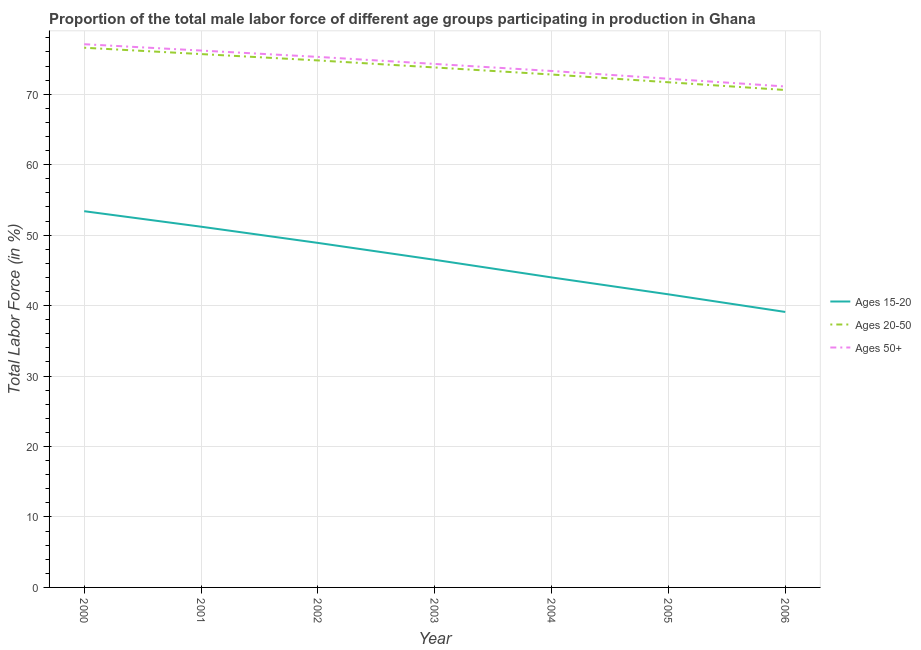How many different coloured lines are there?
Keep it short and to the point. 3. What is the percentage of male labor force above age 50 in 2003?
Your response must be concise. 74.3. Across all years, what is the maximum percentage of male labor force within the age group 15-20?
Give a very brief answer. 53.4. Across all years, what is the minimum percentage of male labor force above age 50?
Offer a terse response. 71.1. In which year was the percentage of male labor force within the age group 20-50 maximum?
Provide a succinct answer. 2000. In which year was the percentage of male labor force above age 50 minimum?
Your answer should be compact. 2006. What is the total percentage of male labor force above age 50 in the graph?
Make the answer very short. 519.5. What is the difference between the percentage of male labor force within the age group 15-20 in 2000 and that in 2001?
Your answer should be very brief. 2.2. What is the difference between the percentage of male labor force within the age group 20-50 in 2002 and the percentage of male labor force above age 50 in 2003?
Offer a terse response. 0.5. What is the average percentage of male labor force within the age group 20-50 per year?
Your answer should be very brief. 73.71. What is the ratio of the percentage of male labor force within the age group 20-50 in 2003 to that in 2006?
Provide a succinct answer. 1.05. Is the percentage of male labor force above age 50 in 2000 less than that in 2004?
Your answer should be very brief. No. What is the difference between the highest and the second highest percentage of male labor force above age 50?
Keep it short and to the point. 0.9. What is the difference between the highest and the lowest percentage of male labor force within the age group 15-20?
Make the answer very short. 14.3. In how many years, is the percentage of male labor force above age 50 greater than the average percentage of male labor force above age 50 taken over all years?
Ensure brevity in your answer.  4. How many years are there in the graph?
Your answer should be very brief. 7. What is the difference between two consecutive major ticks on the Y-axis?
Offer a very short reply. 10. Are the values on the major ticks of Y-axis written in scientific E-notation?
Offer a terse response. No. Does the graph contain grids?
Give a very brief answer. Yes. Where does the legend appear in the graph?
Your answer should be compact. Center right. How are the legend labels stacked?
Keep it short and to the point. Vertical. What is the title of the graph?
Your answer should be very brief. Proportion of the total male labor force of different age groups participating in production in Ghana. What is the label or title of the Y-axis?
Make the answer very short. Total Labor Force (in %). What is the Total Labor Force (in %) of Ages 15-20 in 2000?
Offer a terse response. 53.4. What is the Total Labor Force (in %) in Ages 20-50 in 2000?
Your answer should be very brief. 76.6. What is the Total Labor Force (in %) in Ages 50+ in 2000?
Make the answer very short. 77.1. What is the Total Labor Force (in %) in Ages 15-20 in 2001?
Provide a succinct answer. 51.2. What is the Total Labor Force (in %) of Ages 20-50 in 2001?
Provide a short and direct response. 75.7. What is the Total Labor Force (in %) in Ages 50+ in 2001?
Your answer should be compact. 76.2. What is the Total Labor Force (in %) in Ages 15-20 in 2002?
Offer a very short reply. 48.9. What is the Total Labor Force (in %) of Ages 20-50 in 2002?
Ensure brevity in your answer.  74.8. What is the Total Labor Force (in %) in Ages 50+ in 2002?
Give a very brief answer. 75.3. What is the Total Labor Force (in %) of Ages 15-20 in 2003?
Your answer should be very brief. 46.5. What is the Total Labor Force (in %) of Ages 20-50 in 2003?
Ensure brevity in your answer.  73.8. What is the Total Labor Force (in %) of Ages 50+ in 2003?
Your answer should be very brief. 74.3. What is the Total Labor Force (in %) in Ages 20-50 in 2004?
Give a very brief answer. 72.8. What is the Total Labor Force (in %) in Ages 50+ in 2004?
Ensure brevity in your answer.  73.3. What is the Total Labor Force (in %) of Ages 15-20 in 2005?
Provide a short and direct response. 41.6. What is the Total Labor Force (in %) in Ages 20-50 in 2005?
Your response must be concise. 71.7. What is the Total Labor Force (in %) of Ages 50+ in 2005?
Your answer should be compact. 72.2. What is the Total Labor Force (in %) of Ages 15-20 in 2006?
Your answer should be very brief. 39.1. What is the Total Labor Force (in %) of Ages 20-50 in 2006?
Provide a succinct answer. 70.6. What is the Total Labor Force (in %) in Ages 50+ in 2006?
Offer a very short reply. 71.1. Across all years, what is the maximum Total Labor Force (in %) of Ages 15-20?
Your response must be concise. 53.4. Across all years, what is the maximum Total Labor Force (in %) in Ages 20-50?
Provide a short and direct response. 76.6. Across all years, what is the maximum Total Labor Force (in %) of Ages 50+?
Your response must be concise. 77.1. Across all years, what is the minimum Total Labor Force (in %) of Ages 15-20?
Offer a terse response. 39.1. Across all years, what is the minimum Total Labor Force (in %) of Ages 20-50?
Provide a short and direct response. 70.6. Across all years, what is the minimum Total Labor Force (in %) in Ages 50+?
Offer a terse response. 71.1. What is the total Total Labor Force (in %) of Ages 15-20 in the graph?
Your response must be concise. 324.7. What is the total Total Labor Force (in %) of Ages 20-50 in the graph?
Give a very brief answer. 516. What is the total Total Labor Force (in %) in Ages 50+ in the graph?
Your answer should be very brief. 519.5. What is the difference between the Total Labor Force (in %) of Ages 20-50 in 2000 and that in 2001?
Give a very brief answer. 0.9. What is the difference between the Total Labor Force (in %) in Ages 50+ in 2000 and that in 2001?
Keep it short and to the point. 0.9. What is the difference between the Total Labor Force (in %) of Ages 20-50 in 2000 and that in 2002?
Keep it short and to the point. 1.8. What is the difference between the Total Labor Force (in %) in Ages 50+ in 2000 and that in 2002?
Offer a very short reply. 1.8. What is the difference between the Total Labor Force (in %) in Ages 15-20 in 2000 and that in 2003?
Provide a succinct answer. 6.9. What is the difference between the Total Labor Force (in %) in Ages 15-20 in 2000 and that in 2004?
Give a very brief answer. 9.4. What is the difference between the Total Labor Force (in %) in Ages 20-50 in 2000 and that in 2004?
Provide a succinct answer. 3.8. What is the difference between the Total Labor Force (in %) in Ages 15-20 in 2000 and that in 2005?
Provide a short and direct response. 11.8. What is the difference between the Total Labor Force (in %) of Ages 20-50 in 2000 and that in 2005?
Offer a very short reply. 4.9. What is the difference between the Total Labor Force (in %) of Ages 50+ in 2000 and that in 2005?
Ensure brevity in your answer.  4.9. What is the difference between the Total Labor Force (in %) of Ages 15-20 in 2000 and that in 2006?
Provide a succinct answer. 14.3. What is the difference between the Total Labor Force (in %) in Ages 20-50 in 2000 and that in 2006?
Make the answer very short. 6. What is the difference between the Total Labor Force (in %) of Ages 50+ in 2000 and that in 2006?
Your answer should be very brief. 6. What is the difference between the Total Labor Force (in %) of Ages 50+ in 2001 and that in 2003?
Make the answer very short. 1.9. What is the difference between the Total Labor Force (in %) of Ages 15-20 in 2001 and that in 2004?
Your answer should be very brief. 7.2. What is the difference between the Total Labor Force (in %) of Ages 15-20 in 2001 and that in 2005?
Provide a succinct answer. 9.6. What is the difference between the Total Labor Force (in %) of Ages 15-20 in 2001 and that in 2006?
Make the answer very short. 12.1. What is the difference between the Total Labor Force (in %) in Ages 50+ in 2001 and that in 2006?
Keep it short and to the point. 5.1. What is the difference between the Total Labor Force (in %) in Ages 20-50 in 2002 and that in 2003?
Make the answer very short. 1. What is the difference between the Total Labor Force (in %) in Ages 15-20 in 2002 and that in 2005?
Provide a short and direct response. 7.3. What is the difference between the Total Labor Force (in %) of Ages 50+ in 2002 and that in 2005?
Offer a terse response. 3.1. What is the difference between the Total Labor Force (in %) of Ages 15-20 in 2002 and that in 2006?
Your response must be concise. 9.8. What is the difference between the Total Labor Force (in %) in Ages 20-50 in 2002 and that in 2006?
Provide a short and direct response. 4.2. What is the difference between the Total Labor Force (in %) in Ages 15-20 in 2003 and that in 2004?
Provide a succinct answer. 2.5. What is the difference between the Total Labor Force (in %) in Ages 20-50 in 2003 and that in 2004?
Provide a short and direct response. 1. What is the difference between the Total Labor Force (in %) of Ages 50+ in 2003 and that in 2004?
Ensure brevity in your answer.  1. What is the difference between the Total Labor Force (in %) in Ages 15-20 in 2003 and that in 2005?
Offer a very short reply. 4.9. What is the difference between the Total Labor Force (in %) in Ages 20-50 in 2003 and that in 2005?
Offer a terse response. 2.1. What is the difference between the Total Labor Force (in %) of Ages 20-50 in 2003 and that in 2006?
Offer a terse response. 3.2. What is the difference between the Total Labor Force (in %) in Ages 50+ in 2003 and that in 2006?
Make the answer very short. 3.2. What is the difference between the Total Labor Force (in %) in Ages 15-20 in 2004 and that in 2005?
Provide a succinct answer. 2.4. What is the difference between the Total Labor Force (in %) in Ages 50+ in 2004 and that in 2005?
Your answer should be compact. 1.1. What is the difference between the Total Labor Force (in %) in Ages 15-20 in 2004 and that in 2006?
Your answer should be very brief. 4.9. What is the difference between the Total Labor Force (in %) in Ages 20-50 in 2005 and that in 2006?
Your answer should be very brief. 1.1. What is the difference between the Total Labor Force (in %) of Ages 15-20 in 2000 and the Total Labor Force (in %) of Ages 20-50 in 2001?
Your answer should be compact. -22.3. What is the difference between the Total Labor Force (in %) in Ages 15-20 in 2000 and the Total Labor Force (in %) in Ages 50+ in 2001?
Make the answer very short. -22.8. What is the difference between the Total Labor Force (in %) of Ages 20-50 in 2000 and the Total Labor Force (in %) of Ages 50+ in 2001?
Give a very brief answer. 0.4. What is the difference between the Total Labor Force (in %) of Ages 15-20 in 2000 and the Total Labor Force (in %) of Ages 20-50 in 2002?
Give a very brief answer. -21.4. What is the difference between the Total Labor Force (in %) in Ages 15-20 in 2000 and the Total Labor Force (in %) in Ages 50+ in 2002?
Give a very brief answer. -21.9. What is the difference between the Total Labor Force (in %) in Ages 20-50 in 2000 and the Total Labor Force (in %) in Ages 50+ in 2002?
Your response must be concise. 1.3. What is the difference between the Total Labor Force (in %) of Ages 15-20 in 2000 and the Total Labor Force (in %) of Ages 20-50 in 2003?
Ensure brevity in your answer.  -20.4. What is the difference between the Total Labor Force (in %) of Ages 15-20 in 2000 and the Total Labor Force (in %) of Ages 50+ in 2003?
Make the answer very short. -20.9. What is the difference between the Total Labor Force (in %) in Ages 20-50 in 2000 and the Total Labor Force (in %) in Ages 50+ in 2003?
Keep it short and to the point. 2.3. What is the difference between the Total Labor Force (in %) in Ages 15-20 in 2000 and the Total Labor Force (in %) in Ages 20-50 in 2004?
Your response must be concise. -19.4. What is the difference between the Total Labor Force (in %) in Ages 15-20 in 2000 and the Total Labor Force (in %) in Ages 50+ in 2004?
Offer a terse response. -19.9. What is the difference between the Total Labor Force (in %) of Ages 15-20 in 2000 and the Total Labor Force (in %) of Ages 20-50 in 2005?
Keep it short and to the point. -18.3. What is the difference between the Total Labor Force (in %) in Ages 15-20 in 2000 and the Total Labor Force (in %) in Ages 50+ in 2005?
Your answer should be compact. -18.8. What is the difference between the Total Labor Force (in %) of Ages 20-50 in 2000 and the Total Labor Force (in %) of Ages 50+ in 2005?
Your response must be concise. 4.4. What is the difference between the Total Labor Force (in %) of Ages 15-20 in 2000 and the Total Labor Force (in %) of Ages 20-50 in 2006?
Ensure brevity in your answer.  -17.2. What is the difference between the Total Labor Force (in %) of Ages 15-20 in 2000 and the Total Labor Force (in %) of Ages 50+ in 2006?
Provide a succinct answer. -17.7. What is the difference between the Total Labor Force (in %) in Ages 15-20 in 2001 and the Total Labor Force (in %) in Ages 20-50 in 2002?
Keep it short and to the point. -23.6. What is the difference between the Total Labor Force (in %) in Ages 15-20 in 2001 and the Total Labor Force (in %) in Ages 50+ in 2002?
Provide a short and direct response. -24.1. What is the difference between the Total Labor Force (in %) in Ages 15-20 in 2001 and the Total Labor Force (in %) in Ages 20-50 in 2003?
Give a very brief answer. -22.6. What is the difference between the Total Labor Force (in %) in Ages 15-20 in 2001 and the Total Labor Force (in %) in Ages 50+ in 2003?
Your response must be concise. -23.1. What is the difference between the Total Labor Force (in %) in Ages 15-20 in 2001 and the Total Labor Force (in %) in Ages 20-50 in 2004?
Provide a succinct answer. -21.6. What is the difference between the Total Labor Force (in %) of Ages 15-20 in 2001 and the Total Labor Force (in %) of Ages 50+ in 2004?
Make the answer very short. -22.1. What is the difference between the Total Labor Force (in %) in Ages 20-50 in 2001 and the Total Labor Force (in %) in Ages 50+ in 2004?
Ensure brevity in your answer.  2.4. What is the difference between the Total Labor Force (in %) of Ages 15-20 in 2001 and the Total Labor Force (in %) of Ages 20-50 in 2005?
Provide a succinct answer. -20.5. What is the difference between the Total Labor Force (in %) in Ages 15-20 in 2001 and the Total Labor Force (in %) in Ages 50+ in 2005?
Provide a short and direct response. -21. What is the difference between the Total Labor Force (in %) in Ages 20-50 in 2001 and the Total Labor Force (in %) in Ages 50+ in 2005?
Your answer should be compact. 3.5. What is the difference between the Total Labor Force (in %) of Ages 15-20 in 2001 and the Total Labor Force (in %) of Ages 20-50 in 2006?
Ensure brevity in your answer.  -19.4. What is the difference between the Total Labor Force (in %) of Ages 15-20 in 2001 and the Total Labor Force (in %) of Ages 50+ in 2006?
Give a very brief answer. -19.9. What is the difference between the Total Labor Force (in %) of Ages 15-20 in 2002 and the Total Labor Force (in %) of Ages 20-50 in 2003?
Provide a succinct answer. -24.9. What is the difference between the Total Labor Force (in %) of Ages 15-20 in 2002 and the Total Labor Force (in %) of Ages 50+ in 2003?
Offer a terse response. -25.4. What is the difference between the Total Labor Force (in %) of Ages 20-50 in 2002 and the Total Labor Force (in %) of Ages 50+ in 2003?
Provide a succinct answer. 0.5. What is the difference between the Total Labor Force (in %) of Ages 15-20 in 2002 and the Total Labor Force (in %) of Ages 20-50 in 2004?
Provide a succinct answer. -23.9. What is the difference between the Total Labor Force (in %) in Ages 15-20 in 2002 and the Total Labor Force (in %) in Ages 50+ in 2004?
Offer a terse response. -24.4. What is the difference between the Total Labor Force (in %) of Ages 15-20 in 2002 and the Total Labor Force (in %) of Ages 20-50 in 2005?
Provide a short and direct response. -22.8. What is the difference between the Total Labor Force (in %) in Ages 15-20 in 2002 and the Total Labor Force (in %) in Ages 50+ in 2005?
Your answer should be very brief. -23.3. What is the difference between the Total Labor Force (in %) of Ages 15-20 in 2002 and the Total Labor Force (in %) of Ages 20-50 in 2006?
Offer a very short reply. -21.7. What is the difference between the Total Labor Force (in %) in Ages 15-20 in 2002 and the Total Labor Force (in %) in Ages 50+ in 2006?
Give a very brief answer. -22.2. What is the difference between the Total Labor Force (in %) of Ages 20-50 in 2002 and the Total Labor Force (in %) of Ages 50+ in 2006?
Ensure brevity in your answer.  3.7. What is the difference between the Total Labor Force (in %) in Ages 15-20 in 2003 and the Total Labor Force (in %) in Ages 20-50 in 2004?
Your answer should be very brief. -26.3. What is the difference between the Total Labor Force (in %) of Ages 15-20 in 2003 and the Total Labor Force (in %) of Ages 50+ in 2004?
Provide a succinct answer. -26.8. What is the difference between the Total Labor Force (in %) in Ages 20-50 in 2003 and the Total Labor Force (in %) in Ages 50+ in 2004?
Make the answer very short. 0.5. What is the difference between the Total Labor Force (in %) in Ages 15-20 in 2003 and the Total Labor Force (in %) in Ages 20-50 in 2005?
Provide a succinct answer. -25.2. What is the difference between the Total Labor Force (in %) of Ages 15-20 in 2003 and the Total Labor Force (in %) of Ages 50+ in 2005?
Provide a short and direct response. -25.7. What is the difference between the Total Labor Force (in %) in Ages 20-50 in 2003 and the Total Labor Force (in %) in Ages 50+ in 2005?
Your response must be concise. 1.6. What is the difference between the Total Labor Force (in %) in Ages 15-20 in 2003 and the Total Labor Force (in %) in Ages 20-50 in 2006?
Offer a very short reply. -24.1. What is the difference between the Total Labor Force (in %) in Ages 15-20 in 2003 and the Total Labor Force (in %) in Ages 50+ in 2006?
Offer a very short reply. -24.6. What is the difference between the Total Labor Force (in %) of Ages 15-20 in 2004 and the Total Labor Force (in %) of Ages 20-50 in 2005?
Offer a very short reply. -27.7. What is the difference between the Total Labor Force (in %) of Ages 15-20 in 2004 and the Total Labor Force (in %) of Ages 50+ in 2005?
Keep it short and to the point. -28.2. What is the difference between the Total Labor Force (in %) of Ages 20-50 in 2004 and the Total Labor Force (in %) of Ages 50+ in 2005?
Ensure brevity in your answer.  0.6. What is the difference between the Total Labor Force (in %) of Ages 15-20 in 2004 and the Total Labor Force (in %) of Ages 20-50 in 2006?
Your response must be concise. -26.6. What is the difference between the Total Labor Force (in %) of Ages 15-20 in 2004 and the Total Labor Force (in %) of Ages 50+ in 2006?
Your response must be concise. -27.1. What is the difference between the Total Labor Force (in %) in Ages 15-20 in 2005 and the Total Labor Force (in %) in Ages 50+ in 2006?
Provide a succinct answer. -29.5. What is the average Total Labor Force (in %) in Ages 15-20 per year?
Keep it short and to the point. 46.39. What is the average Total Labor Force (in %) of Ages 20-50 per year?
Your answer should be compact. 73.71. What is the average Total Labor Force (in %) in Ages 50+ per year?
Your answer should be compact. 74.21. In the year 2000, what is the difference between the Total Labor Force (in %) of Ages 15-20 and Total Labor Force (in %) of Ages 20-50?
Make the answer very short. -23.2. In the year 2000, what is the difference between the Total Labor Force (in %) of Ages 15-20 and Total Labor Force (in %) of Ages 50+?
Offer a terse response. -23.7. In the year 2001, what is the difference between the Total Labor Force (in %) in Ages 15-20 and Total Labor Force (in %) in Ages 20-50?
Provide a short and direct response. -24.5. In the year 2001, what is the difference between the Total Labor Force (in %) of Ages 15-20 and Total Labor Force (in %) of Ages 50+?
Provide a short and direct response. -25. In the year 2002, what is the difference between the Total Labor Force (in %) of Ages 15-20 and Total Labor Force (in %) of Ages 20-50?
Give a very brief answer. -25.9. In the year 2002, what is the difference between the Total Labor Force (in %) of Ages 15-20 and Total Labor Force (in %) of Ages 50+?
Your answer should be very brief. -26.4. In the year 2003, what is the difference between the Total Labor Force (in %) of Ages 15-20 and Total Labor Force (in %) of Ages 20-50?
Make the answer very short. -27.3. In the year 2003, what is the difference between the Total Labor Force (in %) of Ages 15-20 and Total Labor Force (in %) of Ages 50+?
Keep it short and to the point. -27.8. In the year 2003, what is the difference between the Total Labor Force (in %) of Ages 20-50 and Total Labor Force (in %) of Ages 50+?
Offer a terse response. -0.5. In the year 2004, what is the difference between the Total Labor Force (in %) in Ages 15-20 and Total Labor Force (in %) in Ages 20-50?
Offer a very short reply. -28.8. In the year 2004, what is the difference between the Total Labor Force (in %) of Ages 15-20 and Total Labor Force (in %) of Ages 50+?
Keep it short and to the point. -29.3. In the year 2004, what is the difference between the Total Labor Force (in %) in Ages 20-50 and Total Labor Force (in %) in Ages 50+?
Keep it short and to the point. -0.5. In the year 2005, what is the difference between the Total Labor Force (in %) of Ages 15-20 and Total Labor Force (in %) of Ages 20-50?
Offer a terse response. -30.1. In the year 2005, what is the difference between the Total Labor Force (in %) of Ages 15-20 and Total Labor Force (in %) of Ages 50+?
Make the answer very short. -30.6. In the year 2005, what is the difference between the Total Labor Force (in %) in Ages 20-50 and Total Labor Force (in %) in Ages 50+?
Give a very brief answer. -0.5. In the year 2006, what is the difference between the Total Labor Force (in %) of Ages 15-20 and Total Labor Force (in %) of Ages 20-50?
Your answer should be compact. -31.5. In the year 2006, what is the difference between the Total Labor Force (in %) of Ages 15-20 and Total Labor Force (in %) of Ages 50+?
Your response must be concise. -32. What is the ratio of the Total Labor Force (in %) of Ages 15-20 in 2000 to that in 2001?
Give a very brief answer. 1.04. What is the ratio of the Total Labor Force (in %) of Ages 20-50 in 2000 to that in 2001?
Ensure brevity in your answer.  1.01. What is the ratio of the Total Labor Force (in %) of Ages 50+ in 2000 to that in 2001?
Your response must be concise. 1.01. What is the ratio of the Total Labor Force (in %) of Ages 15-20 in 2000 to that in 2002?
Your answer should be compact. 1.09. What is the ratio of the Total Labor Force (in %) of Ages 20-50 in 2000 to that in 2002?
Ensure brevity in your answer.  1.02. What is the ratio of the Total Labor Force (in %) in Ages 50+ in 2000 to that in 2002?
Your answer should be very brief. 1.02. What is the ratio of the Total Labor Force (in %) in Ages 15-20 in 2000 to that in 2003?
Your answer should be very brief. 1.15. What is the ratio of the Total Labor Force (in %) in Ages 20-50 in 2000 to that in 2003?
Make the answer very short. 1.04. What is the ratio of the Total Labor Force (in %) of Ages 50+ in 2000 to that in 2003?
Keep it short and to the point. 1.04. What is the ratio of the Total Labor Force (in %) of Ages 15-20 in 2000 to that in 2004?
Keep it short and to the point. 1.21. What is the ratio of the Total Labor Force (in %) of Ages 20-50 in 2000 to that in 2004?
Your answer should be very brief. 1.05. What is the ratio of the Total Labor Force (in %) in Ages 50+ in 2000 to that in 2004?
Your answer should be compact. 1.05. What is the ratio of the Total Labor Force (in %) of Ages 15-20 in 2000 to that in 2005?
Your answer should be very brief. 1.28. What is the ratio of the Total Labor Force (in %) of Ages 20-50 in 2000 to that in 2005?
Make the answer very short. 1.07. What is the ratio of the Total Labor Force (in %) in Ages 50+ in 2000 to that in 2005?
Ensure brevity in your answer.  1.07. What is the ratio of the Total Labor Force (in %) in Ages 15-20 in 2000 to that in 2006?
Keep it short and to the point. 1.37. What is the ratio of the Total Labor Force (in %) in Ages 20-50 in 2000 to that in 2006?
Make the answer very short. 1.08. What is the ratio of the Total Labor Force (in %) of Ages 50+ in 2000 to that in 2006?
Make the answer very short. 1.08. What is the ratio of the Total Labor Force (in %) in Ages 15-20 in 2001 to that in 2002?
Ensure brevity in your answer.  1.05. What is the ratio of the Total Labor Force (in %) in Ages 50+ in 2001 to that in 2002?
Provide a short and direct response. 1.01. What is the ratio of the Total Labor Force (in %) in Ages 15-20 in 2001 to that in 2003?
Your answer should be compact. 1.1. What is the ratio of the Total Labor Force (in %) in Ages 20-50 in 2001 to that in 2003?
Keep it short and to the point. 1.03. What is the ratio of the Total Labor Force (in %) of Ages 50+ in 2001 to that in 2003?
Provide a succinct answer. 1.03. What is the ratio of the Total Labor Force (in %) of Ages 15-20 in 2001 to that in 2004?
Your answer should be very brief. 1.16. What is the ratio of the Total Labor Force (in %) of Ages 20-50 in 2001 to that in 2004?
Your response must be concise. 1.04. What is the ratio of the Total Labor Force (in %) in Ages 50+ in 2001 to that in 2004?
Make the answer very short. 1.04. What is the ratio of the Total Labor Force (in %) in Ages 15-20 in 2001 to that in 2005?
Make the answer very short. 1.23. What is the ratio of the Total Labor Force (in %) of Ages 20-50 in 2001 to that in 2005?
Ensure brevity in your answer.  1.06. What is the ratio of the Total Labor Force (in %) in Ages 50+ in 2001 to that in 2005?
Offer a very short reply. 1.06. What is the ratio of the Total Labor Force (in %) in Ages 15-20 in 2001 to that in 2006?
Make the answer very short. 1.31. What is the ratio of the Total Labor Force (in %) of Ages 20-50 in 2001 to that in 2006?
Give a very brief answer. 1.07. What is the ratio of the Total Labor Force (in %) of Ages 50+ in 2001 to that in 2006?
Your response must be concise. 1.07. What is the ratio of the Total Labor Force (in %) of Ages 15-20 in 2002 to that in 2003?
Your response must be concise. 1.05. What is the ratio of the Total Labor Force (in %) of Ages 20-50 in 2002 to that in 2003?
Provide a short and direct response. 1.01. What is the ratio of the Total Labor Force (in %) in Ages 50+ in 2002 to that in 2003?
Offer a very short reply. 1.01. What is the ratio of the Total Labor Force (in %) of Ages 15-20 in 2002 to that in 2004?
Your response must be concise. 1.11. What is the ratio of the Total Labor Force (in %) in Ages 20-50 in 2002 to that in 2004?
Ensure brevity in your answer.  1.03. What is the ratio of the Total Labor Force (in %) of Ages 50+ in 2002 to that in 2004?
Your response must be concise. 1.03. What is the ratio of the Total Labor Force (in %) of Ages 15-20 in 2002 to that in 2005?
Your answer should be very brief. 1.18. What is the ratio of the Total Labor Force (in %) of Ages 20-50 in 2002 to that in 2005?
Offer a very short reply. 1.04. What is the ratio of the Total Labor Force (in %) of Ages 50+ in 2002 to that in 2005?
Your answer should be very brief. 1.04. What is the ratio of the Total Labor Force (in %) of Ages 15-20 in 2002 to that in 2006?
Make the answer very short. 1.25. What is the ratio of the Total Labor Force (in %) in Ages 20-50 in 2002 to that in 2006?
Provide a succinct answer. 1.06. What is the ratio of the Total Labor Force (in %) of Ages 50+ in 2002 to that in 2006?
Offer a very short reply. 1.06. What is the ratio of the Total Labor Force (in %) in Ages 15-20 in 2003 to that in 2004?
Your answer should be very brief. 1.06. What is the ratio of the Total Labor Force (in %) in Ages 20-50 in 2003 to that in 2004?
Your answer should be compact. 1.01. What is the ratio of the Total Labor Force (in %) in Ages 50+ in 2003 to that in 2004?
Give a very brief answer. 1.01. What is the ratio of the Total Labor Force (in %) in Ages 15-20 in 2003 to that in 2005?
Provide a short and direct response. 1.12. What is the ratio of the Total Labor Force (in %) in Ages 20-50 in 2003 to that in 2005?
Provide a short and direct response. 1.03. What is the ratio of the Total Labor Force (in %) of Ages 50+ in 2003 to that in 2005?
Ensure brevity in your answer.  1.03. What is the ratio of the Total Labor Force (in %) in Ages 15-20 in 2003 to that in 2006?
Keep it short and to the point. 1.19. What is the ratio of the Total Labor Force (in %) in Ages 20-50 in 2003 to that in 2006?
Make the answer very short. 1.05. What is the ratio of the Total Labor Force (in %) in Ages 50+ in 2003 to that in 2006?
Offer a terse response. 1.04. What is the ratio of the Total Labor Force (in %) in Ages 15-20 in 2004 to that in 2005?
Offer a terse response. 1.06. What is the ratio of the Total Labor Force (in %) of Ages 20-50 in 2004 to that in 2005?
Offer a very short reply. 1.02. What is the ratio of the Total Labor Force (in %) in Ages 50+ in 2004 to that in 2005?
Make the answer very short. 1.02. What is the ratio of the Total Labor Force (in %) of Ages 15-20 in 2004 to that in 2006?
Give a very brief answer. 1.13. What is the ratio of the Total Labor Force (in %) of Ages 20-50 in 2004 to that in 2006?
Provide a short and direct response. 1.03. What is the ratio of the Total Labor Force (in %) of Ages 50+ in 2004 to that in 2006?
Your answer should be compact. 1.03. What is the ratio of the Total Labor Force (in %) of Ages 15-20 in 2005 to that in 2006?
Your response must be concise. 1.06. What is the ratio of the Total Labor Force (in %) in Ages 20-50 in 2005 to that in 2006?
Give a very brief answer. 1.02. What is the ratio of the Total Labor Force (in %) of Ages 50+ in 2005 to that in 2006?
Offer a very short reply. 1.02. What is the difference between the highest and the second highest Total Labor Force (in %) in Ages 20-50?
Offer a very short reply. 0.9. What is the difference between the highest and the second highest Total Labor Force (in %) in Ages 50+?
Offer a terse response. 0.9. What is the difference between the highest and the lowest Total Labor Force (in %) in Ages 50+?
Offer a very short reply. 6. 